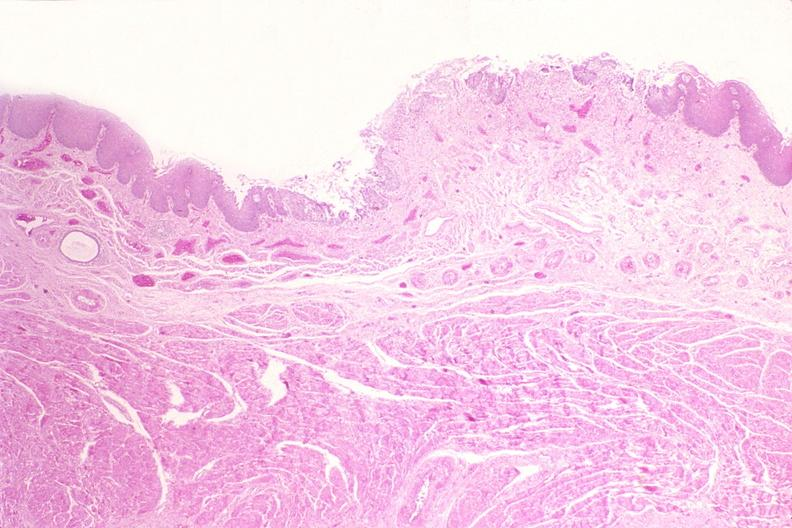does atrophy secondary to pituitectomy show esophagus, herpes, ulcers?
Answer the question using a single word or phrase. No 